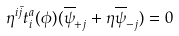Convert formula to latex. <formula><loc_0><loc_0><loc_500><loc_500>\eta ^ { i \bar { j } } t ^ { a } _ { i } ( \phi ) ( \overline { \psi } _ { + j } + \eta \overline { \psi } _ { - j } ) = 0</formula> 